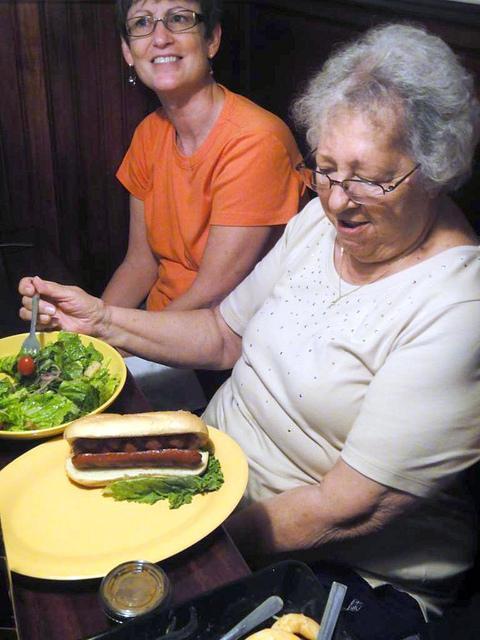How many people are in the photo?
Give a very brief answer. 2. How many kites are there?
Give a very brief answer. 0. 